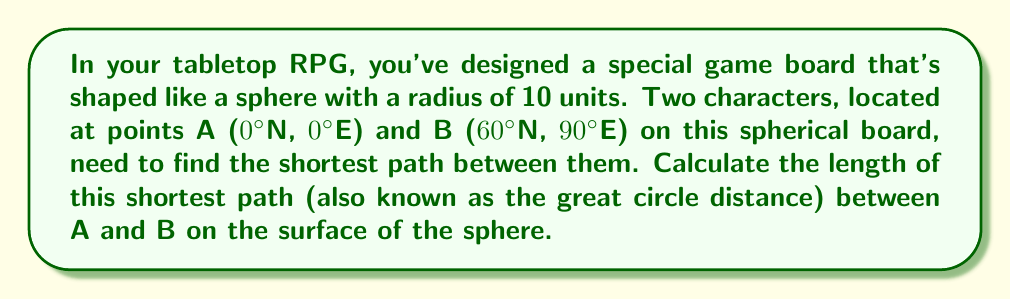Can you answer this question? To solve this problem, we need to use the concept of great circle distance on a sphere, which is analogous to geodesics on a manifold. This is relevant to non-Euclidean geometry, as the surface of a sphere is a non-Euclidean space.

Step 1: Convert the coordinates to radians.
For point A: (0°N, 0°E) = (0, 0) in radians
For point B: (60°N, 90°E) = ($\frac{\pi}{3}$, $\frac{\pi}{2}$) in radians

Step 2: Use the spherical law of cosines formula to calculate the central angle $\theta$ between the two points:

$$\cos(\theta) = \sin(\phi_1)\sin(\phi_2) + \cos(\phi_1)\cos(\phi_2)\cos(\Delta \lambda)$$

Where:
$\phi_1$ and $\phi_2$ are the latitudes of points A and B
$\Delta \lambda$ is the difference in longitude

Substituting the values:

$$\cos(\theta) = \sin(0)\sin(\frac{\pi}{3}) + \cos(0)\cos(\frac{\pi}{3})\cos(\frac{\pi}{2})$$

$$\cos(\theta) = 0 \cdot \frac{\sqrt{3}}{2} + 1 \cdot \frac{1}{2} \cdot 0 = 0$$

$$\theta = \arccos(0) = \frac{\pi}{2}$$

Step 3: Calculate the great circle distance $d$ using the formula:

$$d = R\theta$$

Where $R$ is the radius of the sphere (10 units in this case)

$$d = 10 \cdot \frac{\pi}{2} = 5\pi$$

Therefore, the shortest path between A and B on the spherical game board is $5\pi$ units long.
Answer: $5\pi$ units 